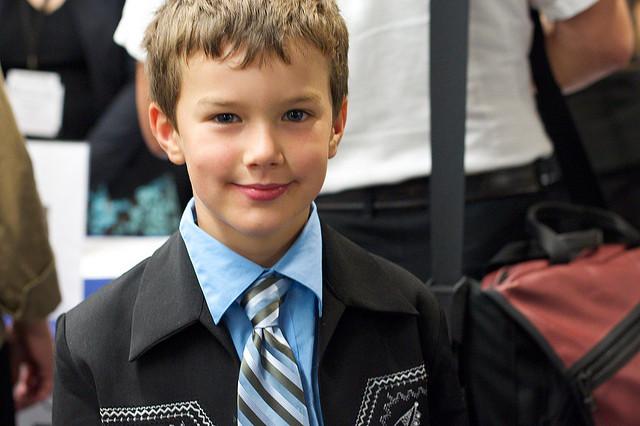What color belt is the man with the white shirt wearing?
Quick response, please. Black. Does this boy look happy?
Write a very short answer. Yes. Why do the boy's eyes look different from one another?
Give a very brief answer. Yes. 